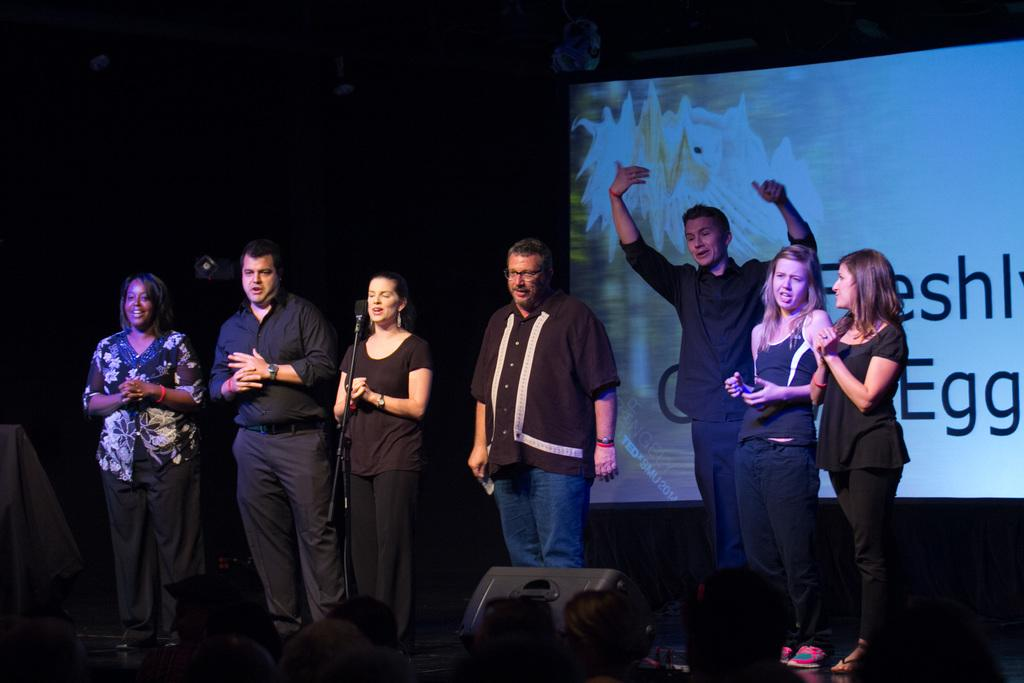Who is present in the image? There are men and women in the image. Where are they located? They are standing on a stage. What are they wearing? They are wearing black dresses. What can be seen behind them? There is a screen behind them. How many minutes does it take for the heart to beat in the image? There is no heart present in the image, so it is not possible to determine the number of minutes it takes for a heart to beat. 